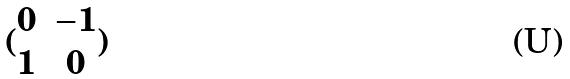<formula> <loc_0><loc_0><loc_500><loc_500>( \begin{matrix} 0 & - 1 \\ 1 & 0 \end{matrix} )</formula> 